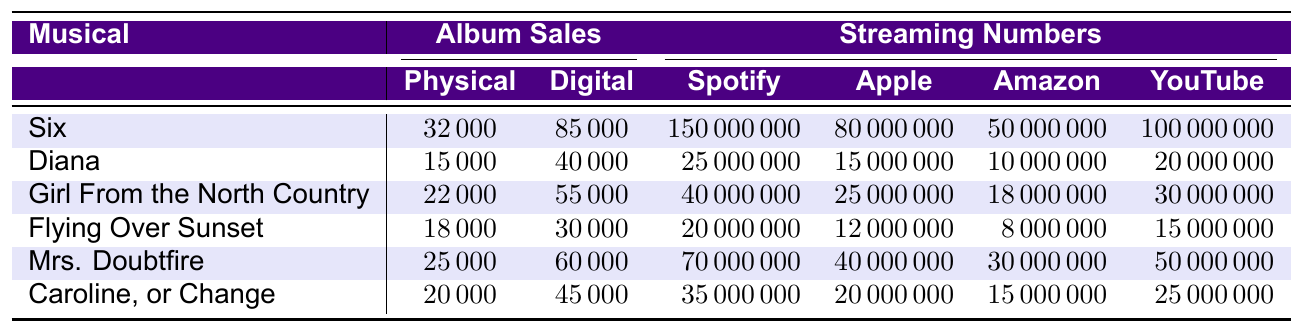What are the physical album sales for "Six"? According to the table, the physical album sales for "Six" is listed as 32,000.
Answer: 32,000 Which musical had the highest digital album sales? "Six" has the highest digital album sales of 85,000 compared to the other musicals listed.
Answer: Six What is the total number of Spotify streams for "Mrs. Doubtfire" and "Caroline, or Change"? The Spotify streams for "Mrs. Doubtfire" are 70,000,000 and for "Caroline, or Change" are 35,000,000. Adding these gives 70,000,000 + 35,000,000 = 105,000,000.
Answer: 105,000,000 Did "Diana" achieve more than 20,000,000 streams on YouTube Music? The table shows that "Diana" had 20,000,000 YouTube Music streams, which means it did not exceed that number.
Answer: No What is the average number of physical album sales across all the musicals? There are six musicals with physical album sales of 32,000, 15,000, 22,000, 18,000, 25,000, and 20,000. The total is (32,000 + 15,000 + 22,000 + 18,000 + 25,000 + 20,000) = 132,000. Dividing by 6 gives an average of 132,000 / 6 = 22,000.
Answer: 22,000 Which streaming service had the most streams for "Girl From the North Country"? According to the table, "Girl From the North Country" had the most streams on Spotify, with 40,000,000 streams compared to the other services listed.
Answer: Spotify Calculate the difference in physical album sales between "Mrs. Doubtfire" and "Flying Over Sunset". "Mrs. Doubtfire" had physical album sales of 25,000, while "Flying Over Sunset" had 18,000. The difference is 25,000 - 18,000 = 7,000.
Answer: 7,000 Is the total of Apple Music streams for "Six" and "Diana" greater than that of "Mrs. Doubtfire"? The Apple Music streams for "Six" and "Diana" are 80,000,000 and 15,000,000 respectively, totaling 95,000,000. "Mrs. Doubtfire" has 40,000,000 streams. Since 95,000,000 > 40,000,000, the answer is yes.
Answer: Yes What is the median number of Spotify streams for the musicals listed? The Spotify streams sorted are 20,000,000, 25,000,000, 35,000,000, 40,000,000, 70,000,000, 150,000,000. The median lies between the third and fourth value: (40,000,000 + 70,000,000) / 2 = 55,000,000.
Answer: 55,000,000 Which musical had the least physical album sales? The table shows "Diana" with 15,000 physical album sales, which is the least among all listed musicals.
Answer: Diana 